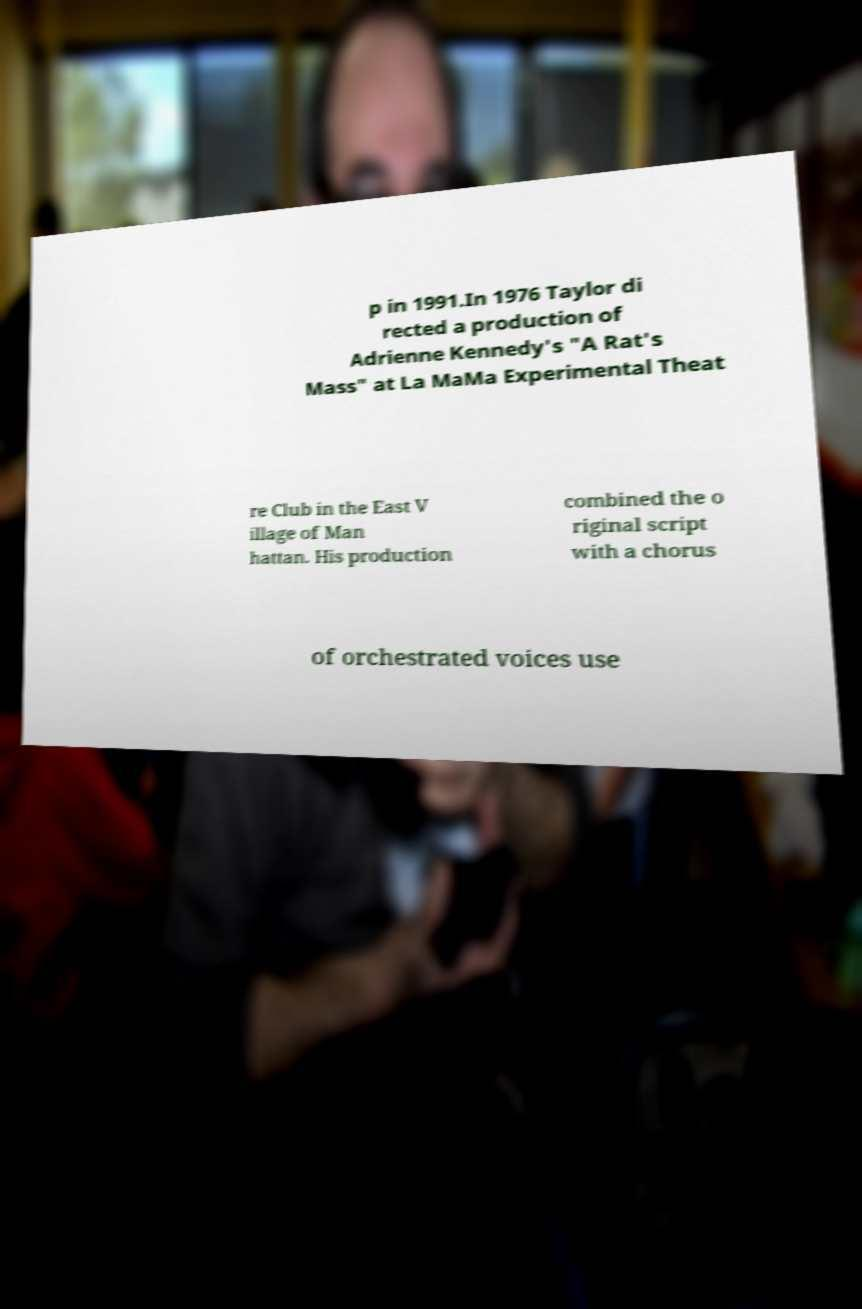I need the written content from this picture converted into text. Can you do that? p in 1991.In 1976 Taylor di rected a production of Adrienne Kennedy's "A Rat's Mass" at La MaMa Experimental Theat re Club in the East V illage of Man hattan. His production combined the o riginal script with a chorus of orchestrated voices use 